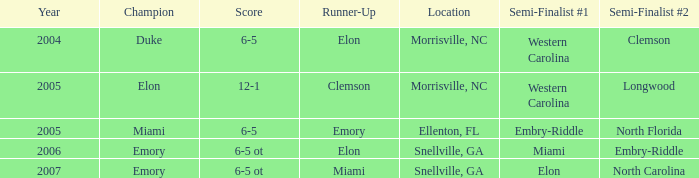Enumerate the scores of every game when miami was positioned as the initial semi-finalist. 6-5 ot. 